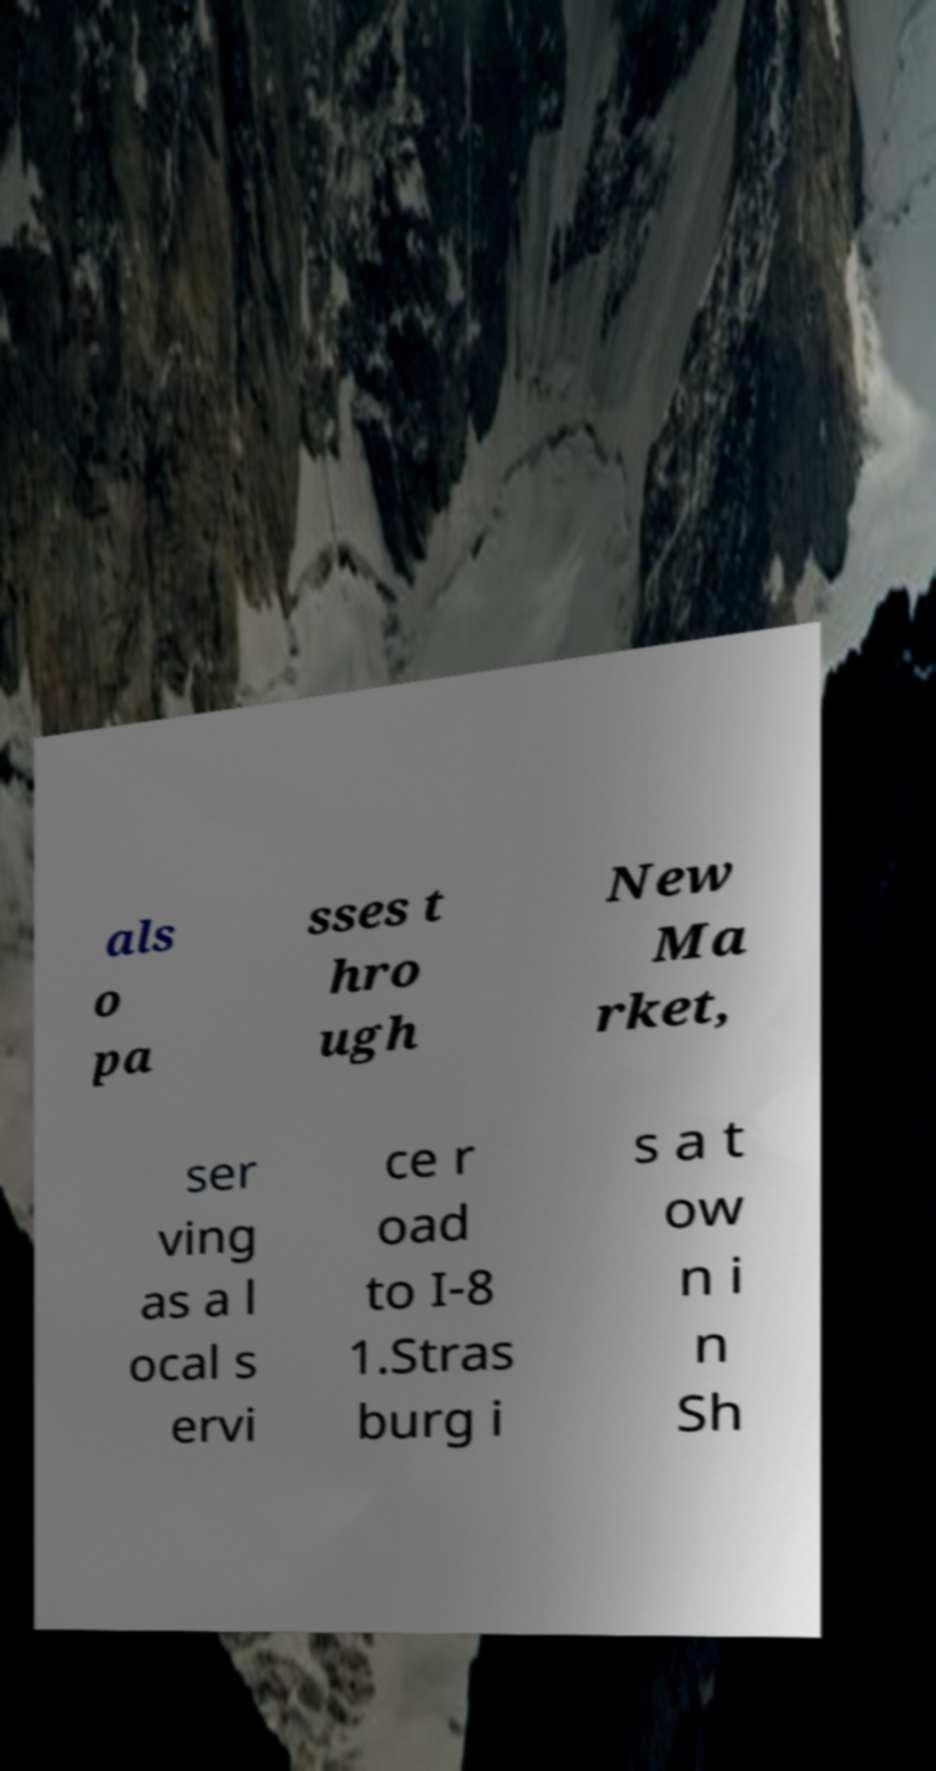What messages or text are displayed in this image? I need them in a readable, typed format. als o pa sses t hro ugh New Ma rket, ser ving as a l ocal s ervi ce r oad to I-8 1.Stras burg i s a t ow n i n Sh 